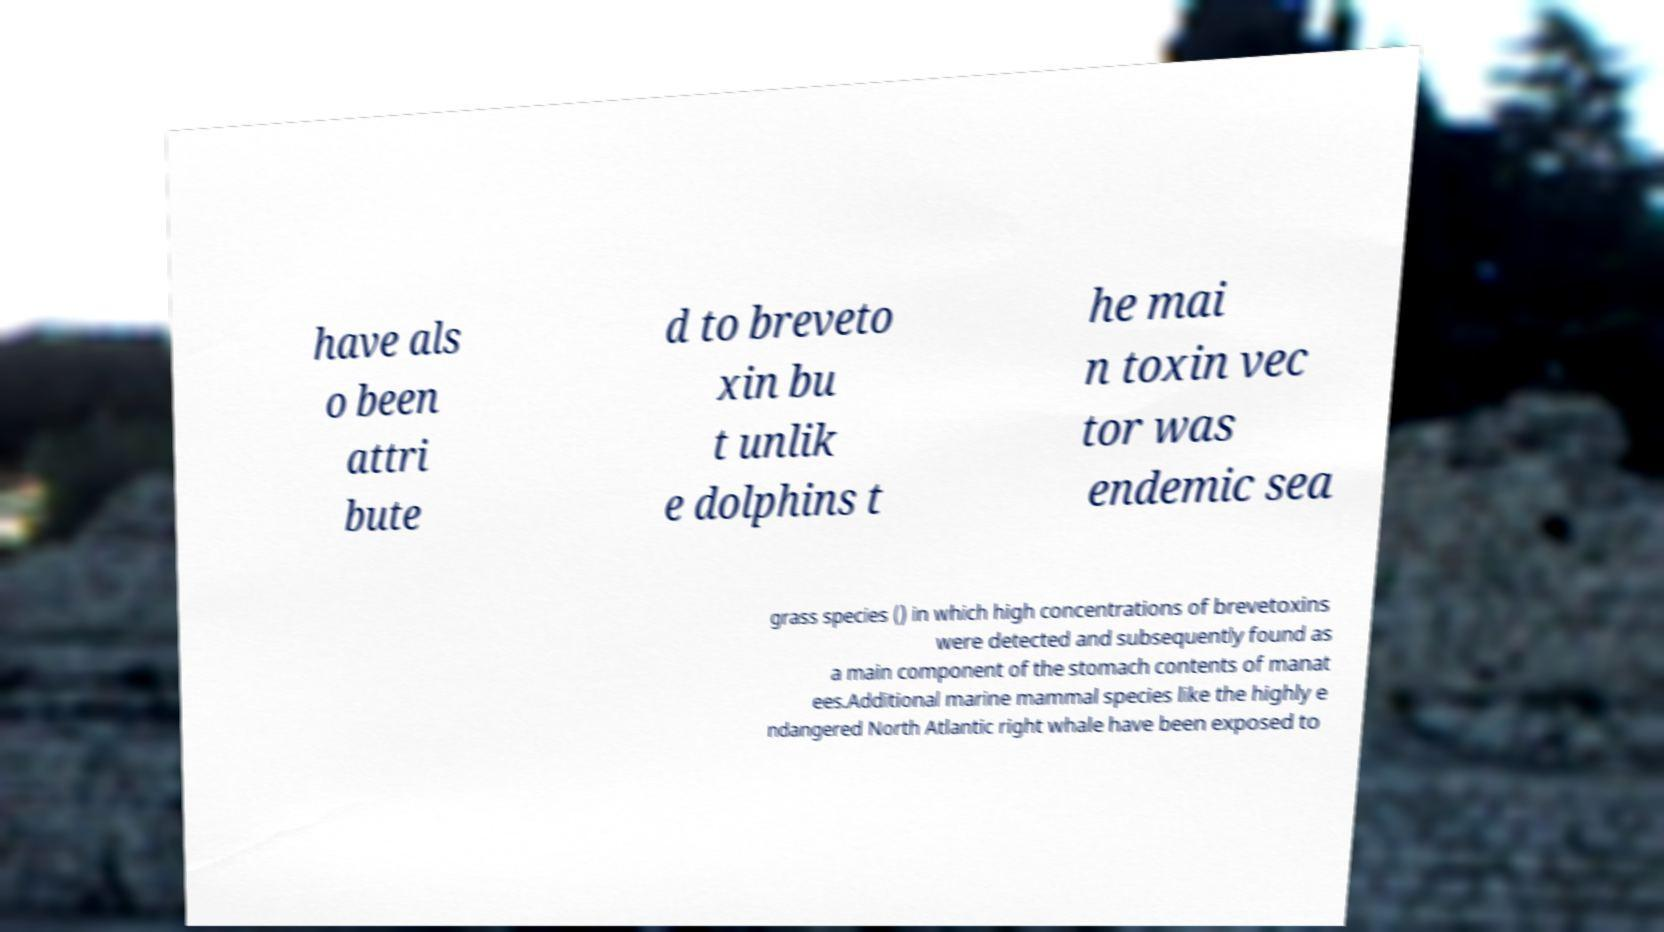Please read and relay the text visible in this image. What does it say? have als o been attri bute d to breveto xin bu t unlik e dolphins t he mai n toxin vec tor was endemic sea grass species () in which high concentrations of brevetoxins were detected and subsequently found as a main component of the stomach contents of manat ees.Additional marine mammal species like the highly e ndangered North Atlantic right whale have been exposed to 